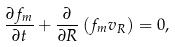<formula> <loc_0><loc_0><loc_500><loc_500>\frac { \partial f _ { m } } { \partial t } + \frac { \partial } { \partial R } \left ( f _ { m } v _ { R } \right ) = 0 ,</formula> 